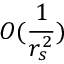Convert formula to latex. <formula><loc_0><loc_0><loc_500><loc_500>O ( \frac { 1 } { r _ { s } ^ { 2 } } )</formula> 